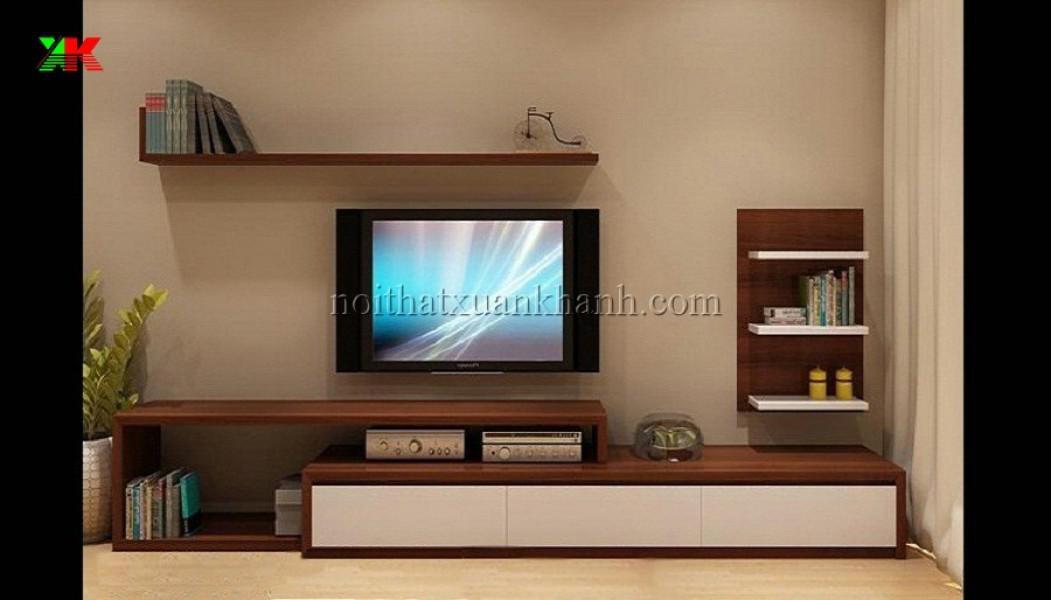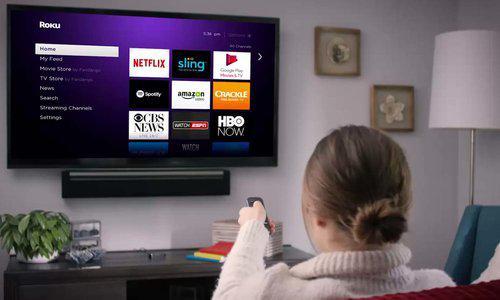The first image is the image on the left, the second image is the image on the right. Analyze the images presented: Is the assertion "Someone is watching TV white sitting on a couch in the right image." valid? Answer yes or no. Yes. The first image is the image on the left, the second image is the image on the right. For the images shown, is this caption "There is only one tv in each image" true? Answer yes or no. Yes. 